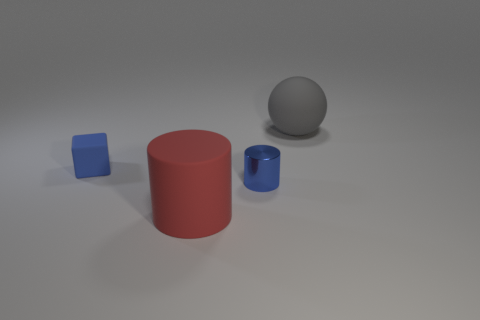Add 4 tiny purple balls. How many objects exist? 8 Subtract all cubes. How many objects are left? 3 Subtract 1 blocks. How many blocks are left? 0 Subtract all blue balls. Subtract all yellow blocks. How many balls are left? 1 Subtract all red rubber cylinders. Subtract all large cylinders. How many objects are left? 2 Add 3 blue things. How many blue things are left? 5 Add 1 small blocks. How many small blocks exist? 2 Subtract all blue cylinders. How many cylinders are left? 1 Subtract 0 yellow spheres. How many objects are left? 4 